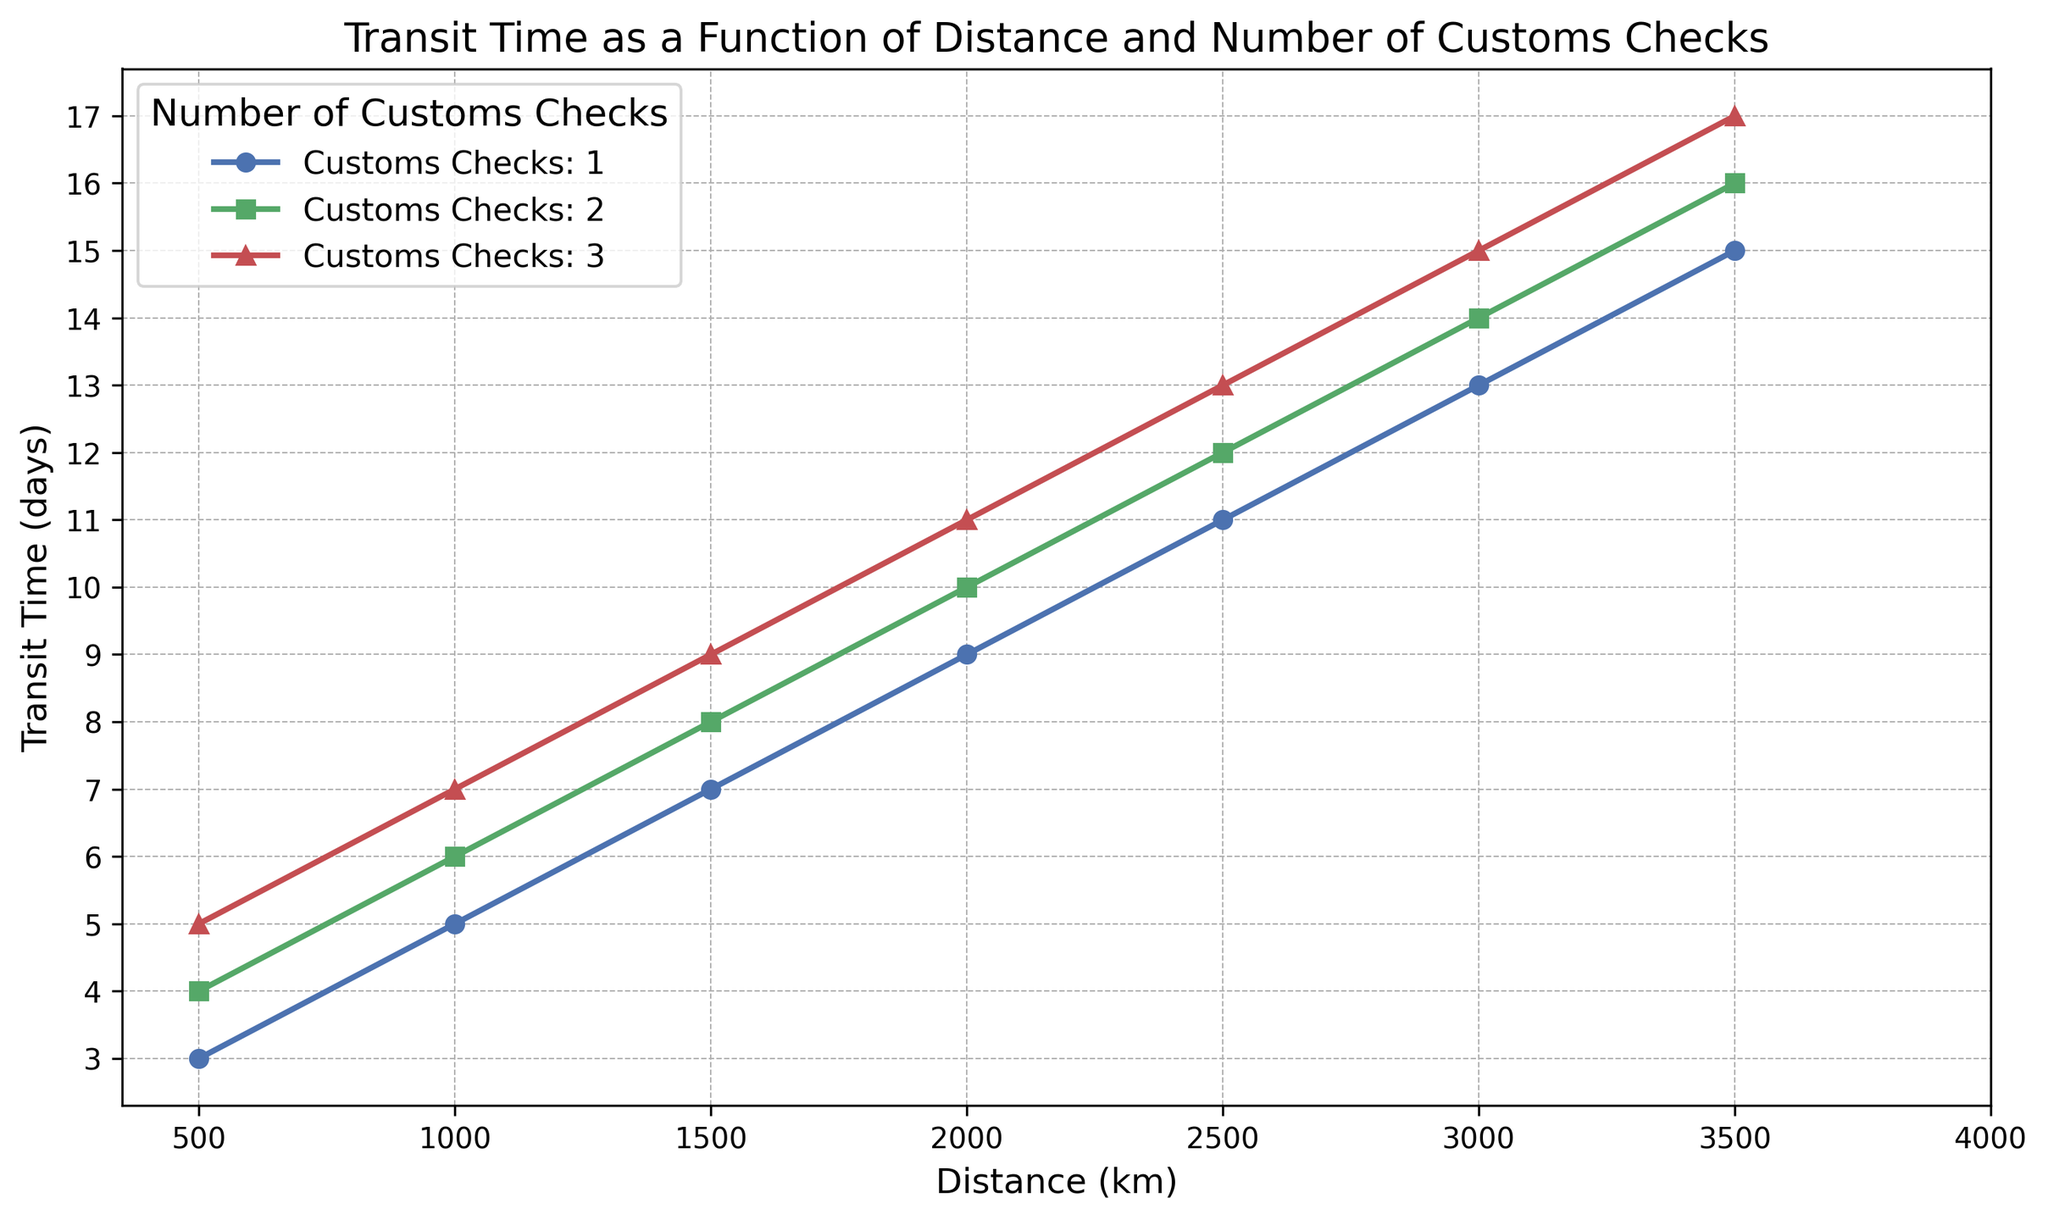What is the transit time for a distance of 1000 km with 2 customs checks? Locate the line representing 2 customs checks and find the corresponding point at the distance of 1000 km. The transit time is 6 days.
Answer: 6 days How much does the transit time increase when going from 1 to 3 customs checks for a distance of 500 km? Find the transit times for 1 customs check and 3 customs checks at 500 km distance, which are 3 days and 5 days respectively. The increase is 5 - 3 = 2 days.
Answer: 2 days Which distance has a transit time of 7 days with 1 customs check? Locate the line representing 1 customs check and find the distance corresponding to a transit time of 7 days. The distance is 1500 km.
Answer: 1500 km Is the increase in transit time from 2000 km to 3000 km greater with 1 or 3 customs checks? Calculate the increase in transit time from 2000 km to 3000 km. For 1 customs check, the increase is 13 - 9 = 4 days. For 3 customs checks, the increase is 15 - 11 = 4 days. Both increases are equal.
Answer: Equal What is the average transit time for 2000 km across all customs checks? Add the transit times for 2000 km: 9 days (1 check), 10 days (2 checks), 11 days (3 checks). Average is (9 + 10 + 11) / 3 = 10 days.
Answer: 10 days How much does transit time increase on average for each additional customs check at a distance of 1500 km? Find the transit times for 1, 2, and 3 customs checks at 1500 km: 7, 8, and 9 days. Calculate the increases: from 7 to 8 (1 day), and from 8 to 9 (1 day). Average increase is (1 + 1) / 2 = 1 day.
Answer: 1 day What is the difference in transit time between 2500 km with 1 customs check and 1000 km with 2 customs checks? Find the transit times for these distances: 11 days (2500 km, 1 check) and 6 days (1000 km, 2 checks). Difference is 11 - 6 = 5 days.
Answer: 5 days How does the transit time curve for 3 customs checks compare to the curve for 1 customs check? Visually inspect the curves. The curve for 3 customs checks is consistently above the curve for 1 customs check, indicating longer transit times for increasing customs checks at each distance.
Answer: 3 checks curve is above What is the transit time difference between the shortest and longest distances for 2 customs checks? Find the transit times for the shortest (500 km) and longest (3500 km) distances with 2 customs checks: 4 and 16 days respectively. Difference is 16 - 4 = 12 days.
Answer: 12 days 